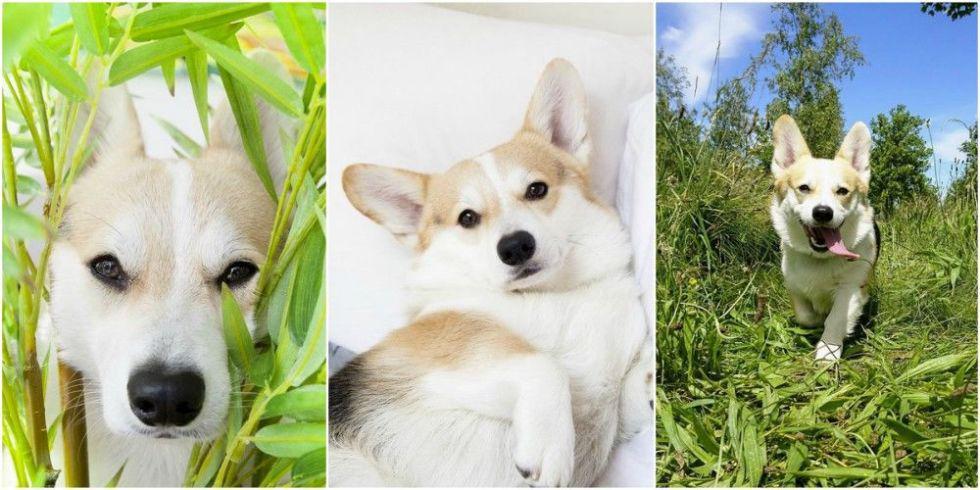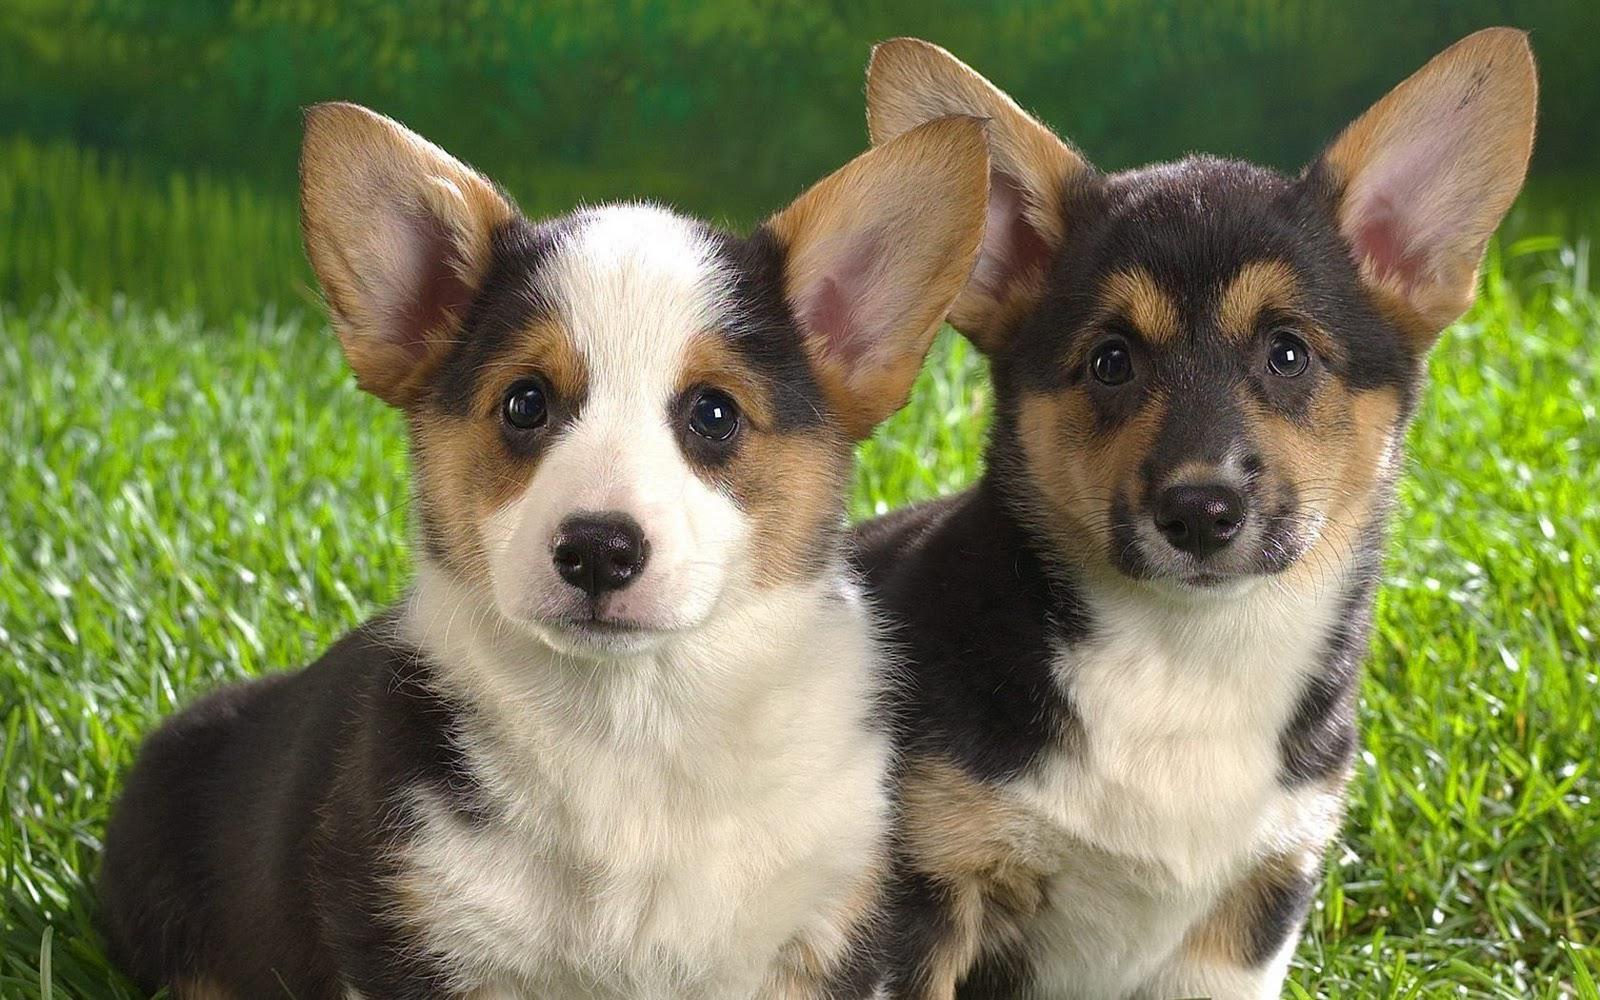The first image is the image on the left, the second image is the image on the right. For the images shown, is this caption "An image includes an orange-and-white dog walking toward the camera on grass." true? Answer yes or no. Yes. 